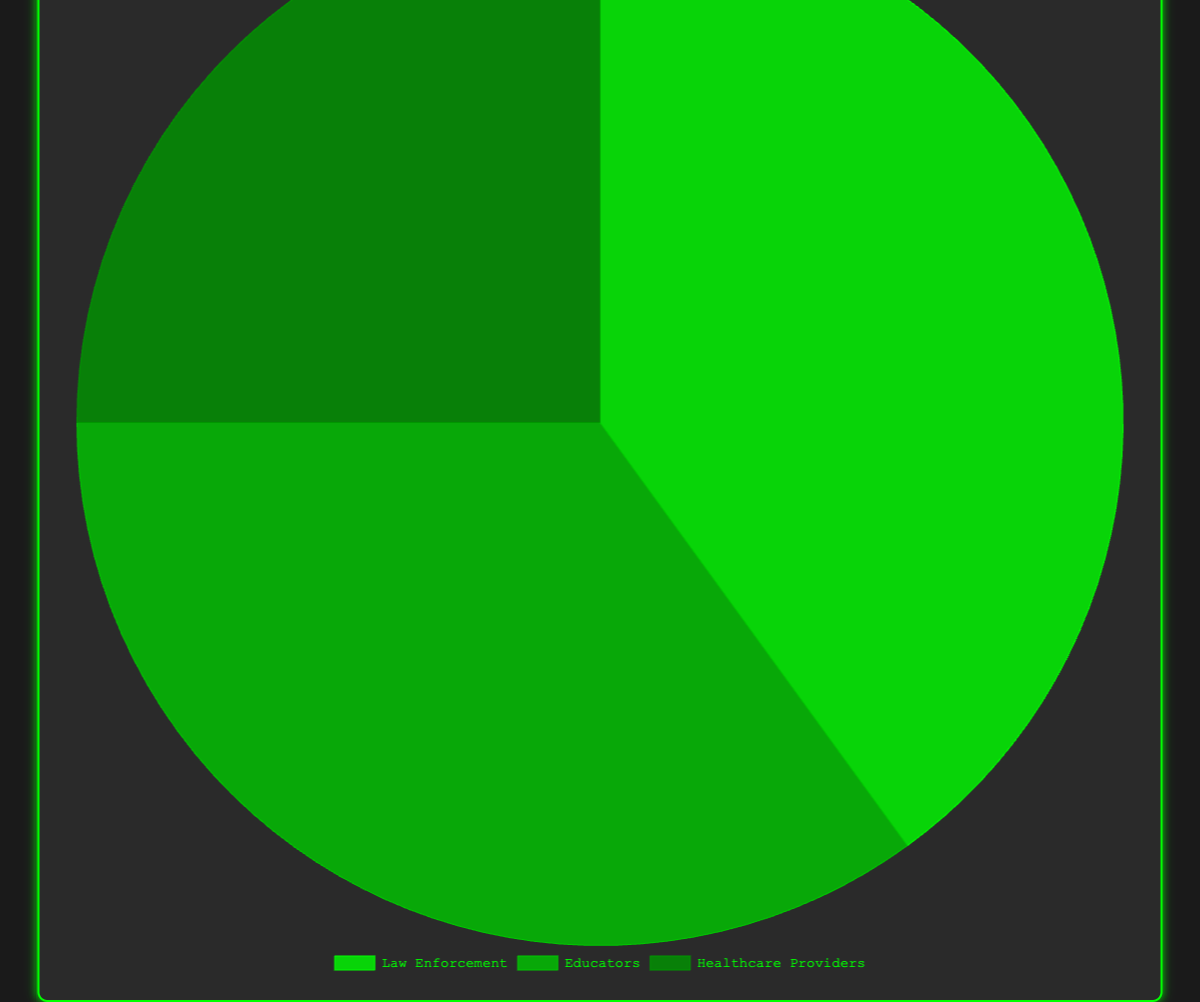Which stakeholder group has the largest share in drug prevention initiatives? By visually inspecting the pie chart, the 'Law Enforcement' segment takes up the largest portion of the pie chart, indicating they have the largest share.
Answer: Law Enforcement How much larger is the share of Law Enforcement compared to Healthcare Providers? Law Enforcement has 40%, and Healthcare Providers have 25%. The difference is 40% - 25% = 15%.
Answer: 15% If Educators and Healthcare Providers combine their efforts, what percentage of the total would they cover? Educators have 35% and Healthcare Providers have 25%. Combined share is 35% + 25% = 60%.
Answer: 60% What stakeholder group has the smallest representation, and what is their percentage share? By visually inspecting the pie chart, the 'Healthcare Providers' segment takes up the smallest portion of the pie chart, indicating they have the smallest share. Their percentage is 25%.
Answer: Healthcare Providers, 25% Are Educators’ contributions in drug prevention initiatives more than half of Law Enforcement's contributions? Law Enforcement has 40%, and half of that is 40% / 2 = 20%. Educators have 35%, which is more than 20%.
Answer: Yes What is the difference in percentage share between the two largest stakeholder groups? The two largest groups are Law Enforcement (40%) and Educators (35%). The difference is 40% - 35% = 5%.
Answer: 5% What fraction of the pie chart does Law Enforcement cover visually? Law Enforcement covers 40% of the pie chart. In fractional form, 40% is equivalent to 40/100 or 2/5.
Answer: 2/5 What is the average percentage of all stakeholder groups? The sum of the percentages is 40% + 35% + 25% = 100%. The average is 100% / 3 = 33.33%.
Answer: 33.33% Compare the combined share of Law Enforcement and Educators with that of Healthcare Providers. Which is greater and by how much? The combined share of Law Enforcement and Educators is 40% + 35% = 75%. Healthcare Providers have 25%. The combined share is greater by 75% - 25% = 50%.
Answer: Combined share is greater by 50% Visually, which stakeholder group is represented by the darkest shade of green on the pie chart? By visually inspecting the pie chart, the 'Healthcare Providers' section is represented by the darkest shade of green among the stakeholders.
Answer: Healthcare Providers 